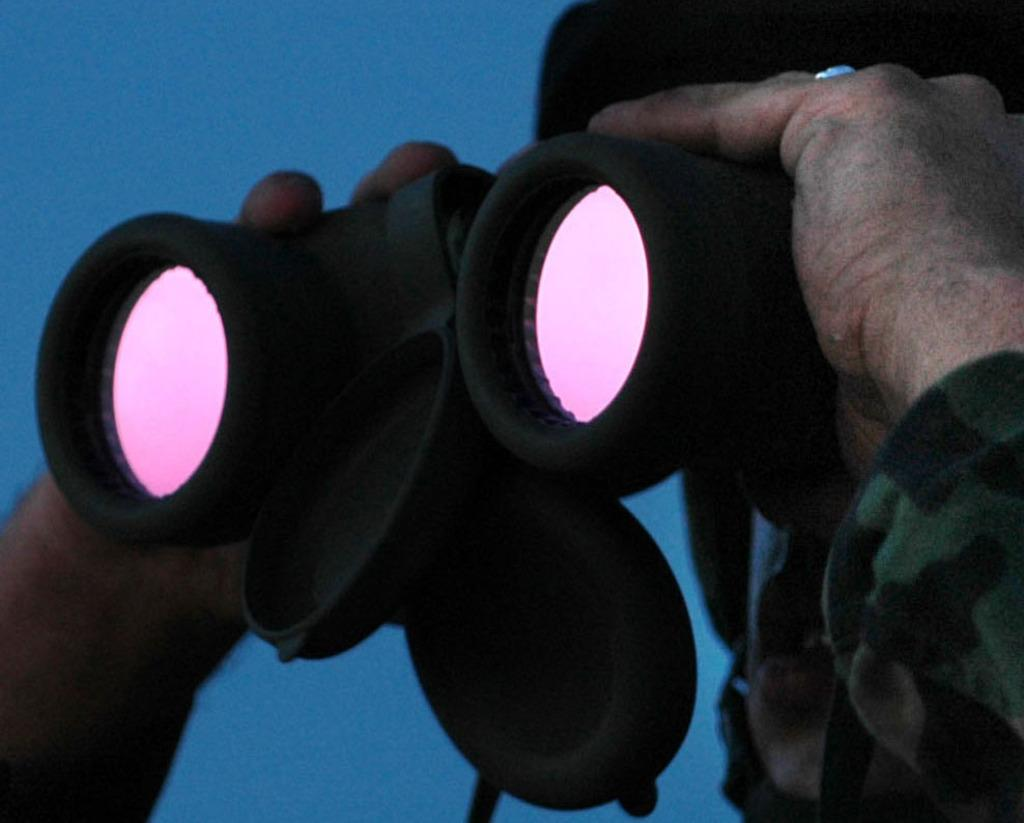Who or what is present in the image? There is a person in the image. What is the person holding in the image? The person's hands are holding a binocular. Can you describe the background of the image? There is a blue color in the background of the image. What type of chain is the person wearing in the image? There is no chain visible in the image; the person is holding a binocular. 